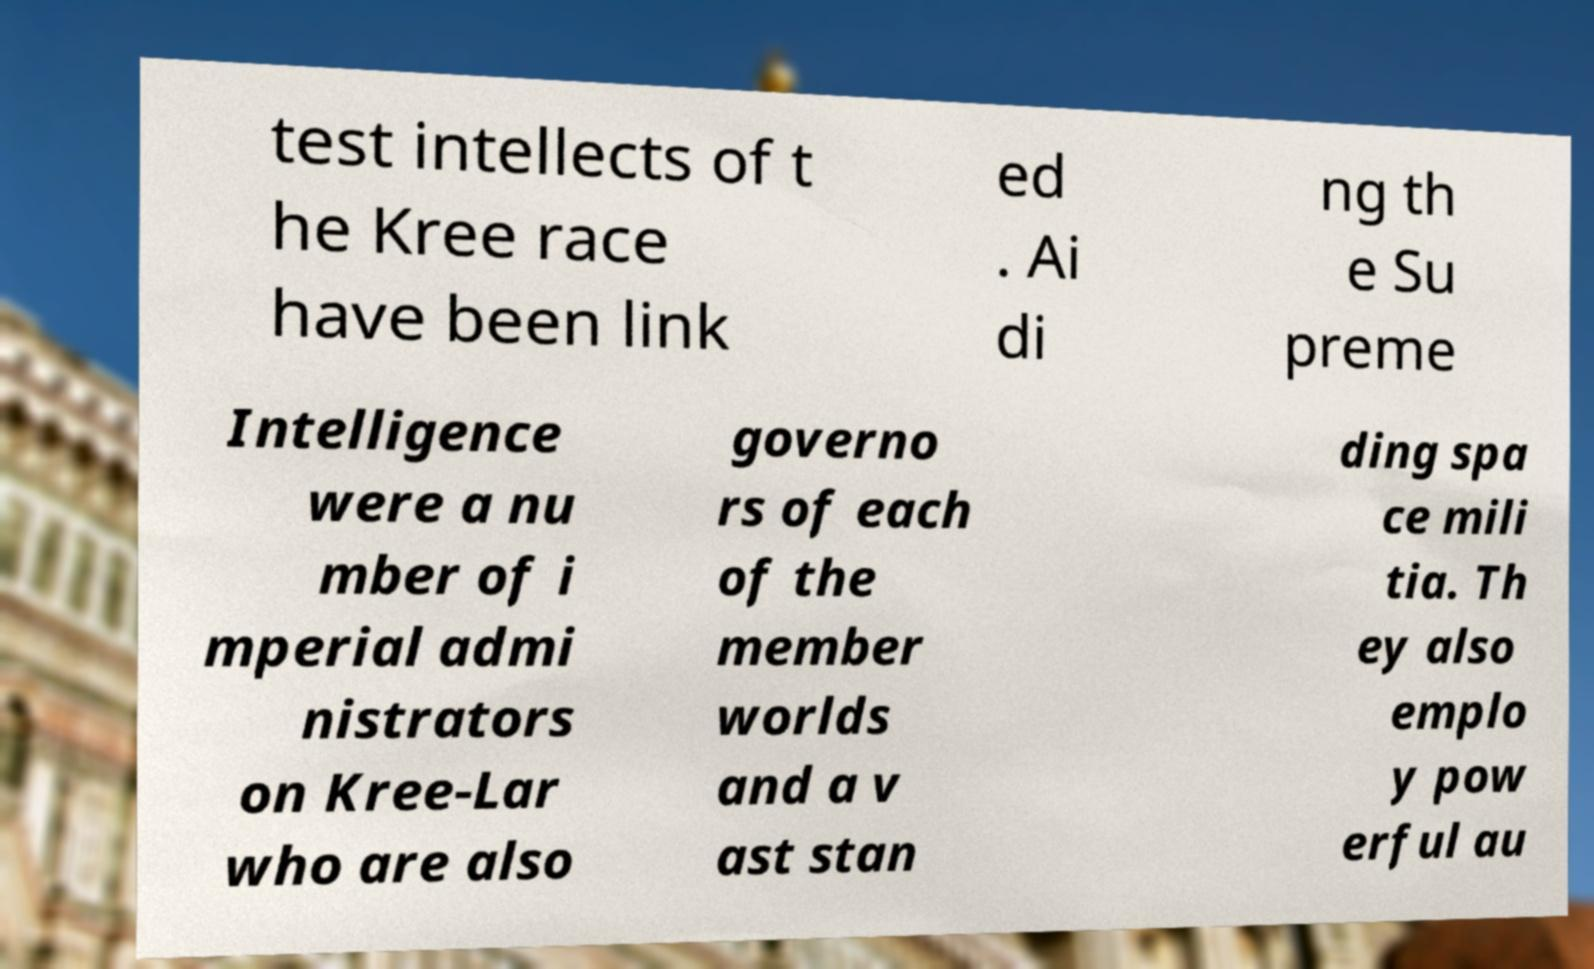Could you extract and type out the text from this image? test intellects of t he Kree race have been link ed . Ai di ng th e Su preme Intelligence were a nu mber of i mperial admi nistrators on Kree-Lar who are also governo rs of each of the member worlds and a v ast stan ding spa ce mili tia. Th ey also emplo y pow erful au 